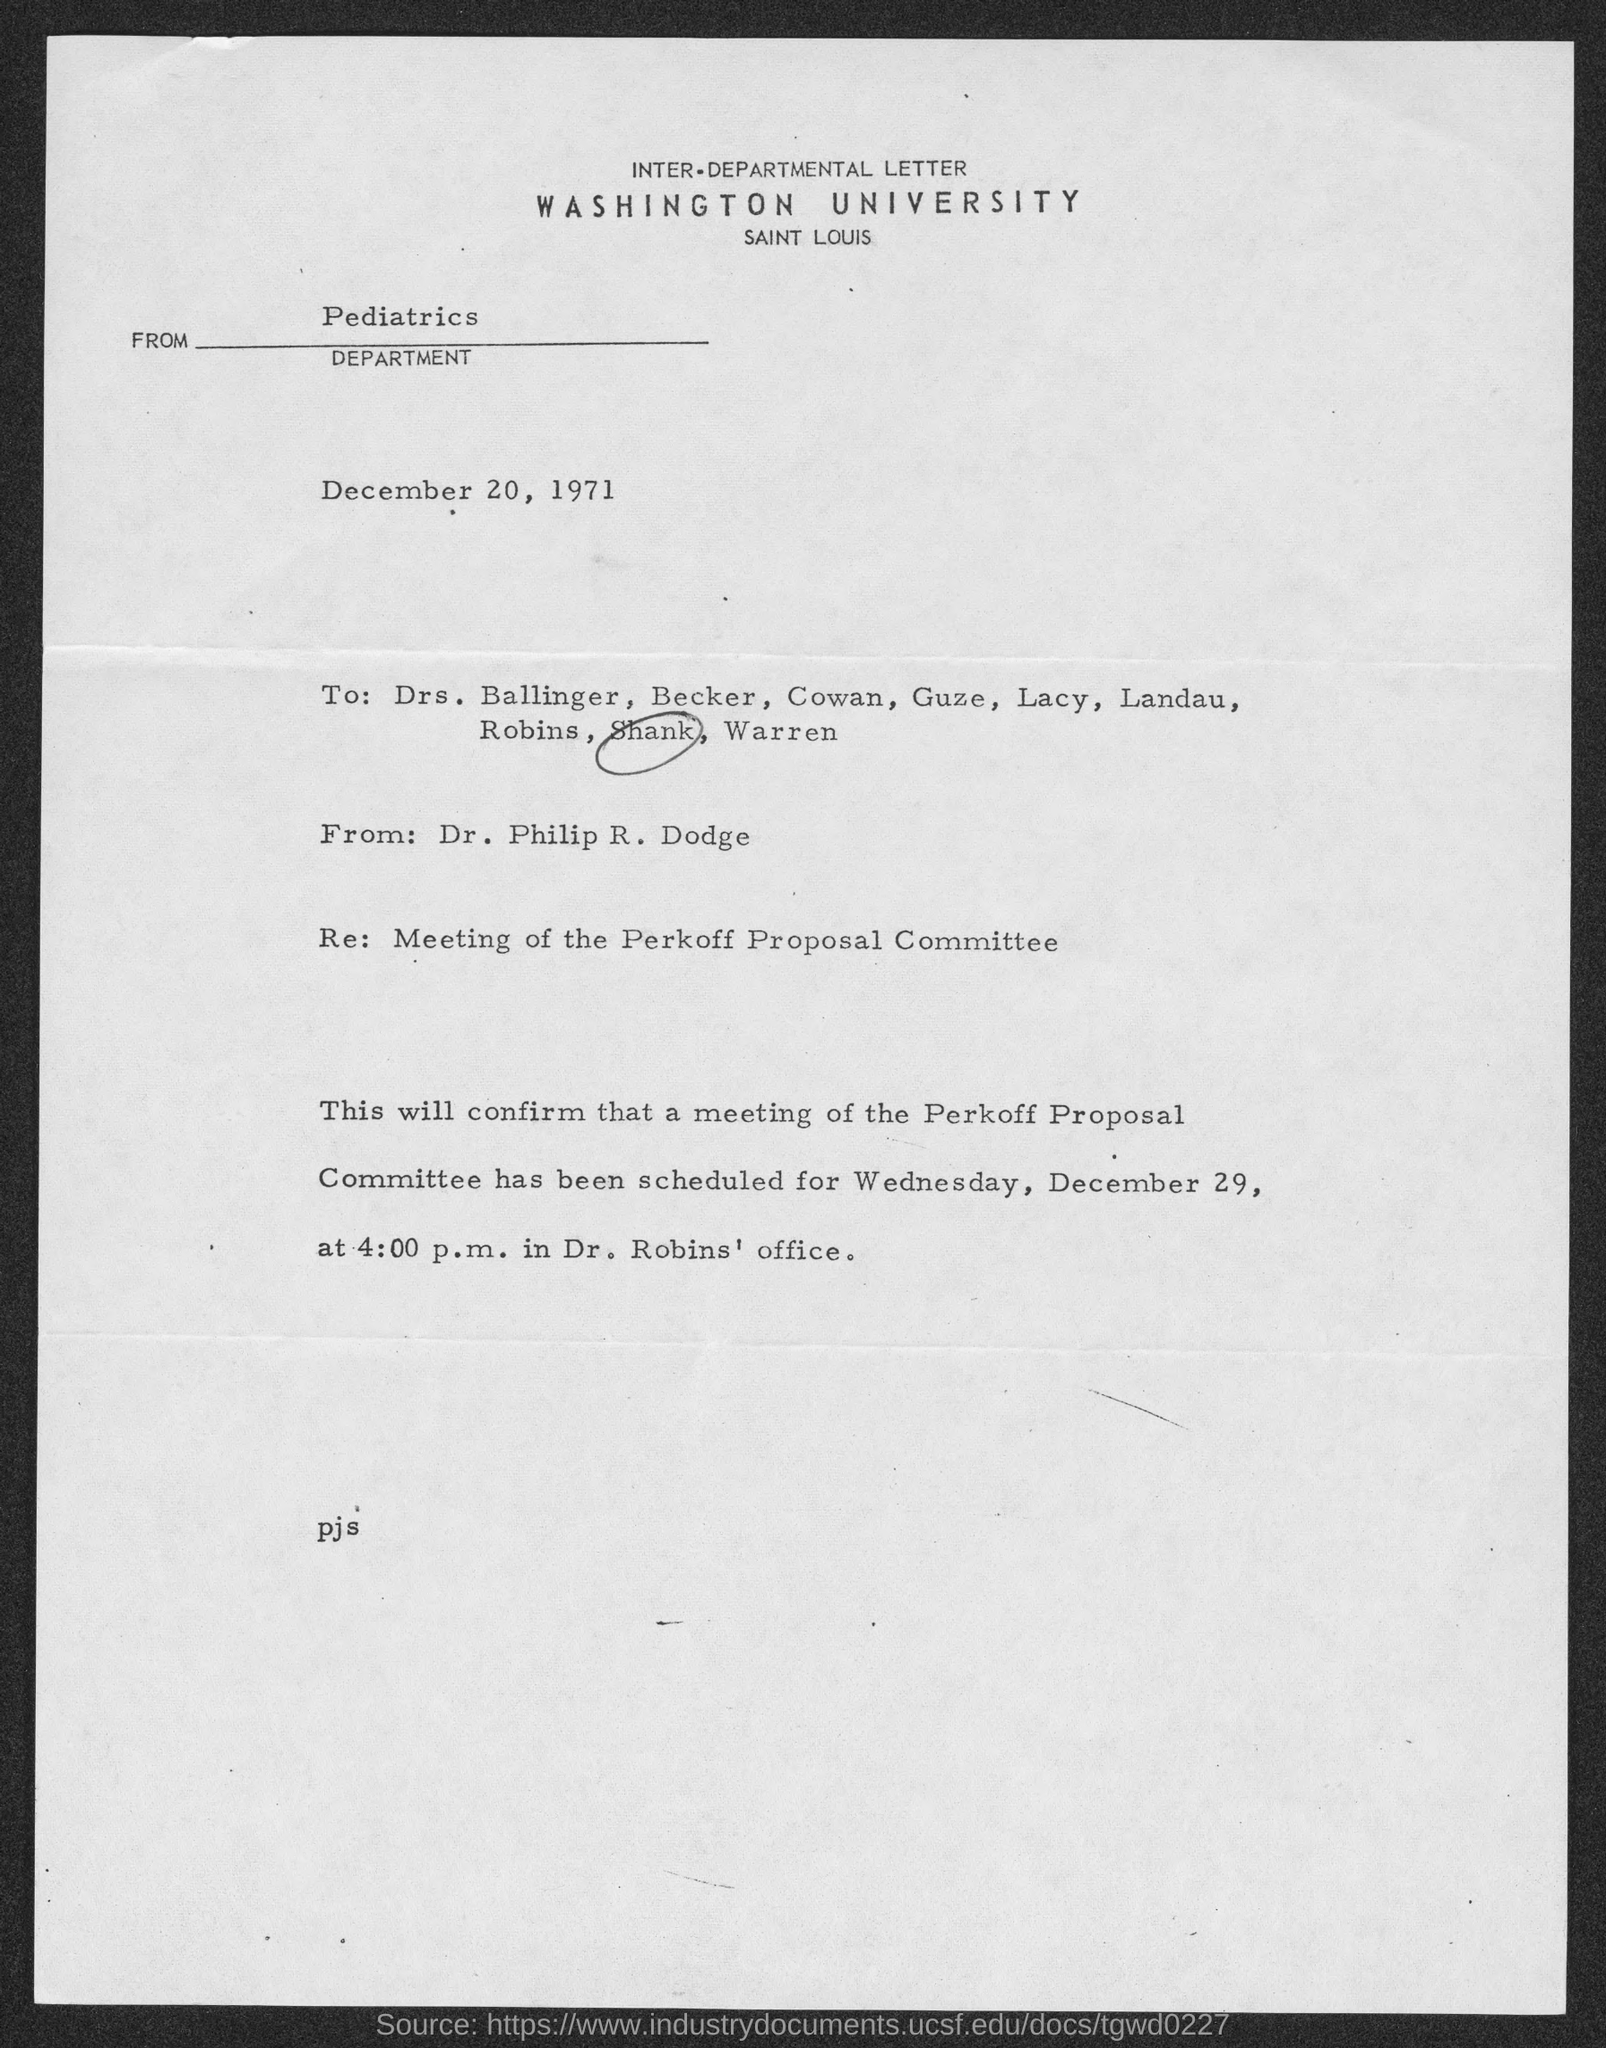What is the address of washington university ?
Your response must be concise. Saint Louis. When is the inter-departmental-letter dated?
Provide a succinct answer. December 20, 1971. What is the day of the week scheduled for perkoff proposal committee ?
Offer a terse response. Wednesday. 